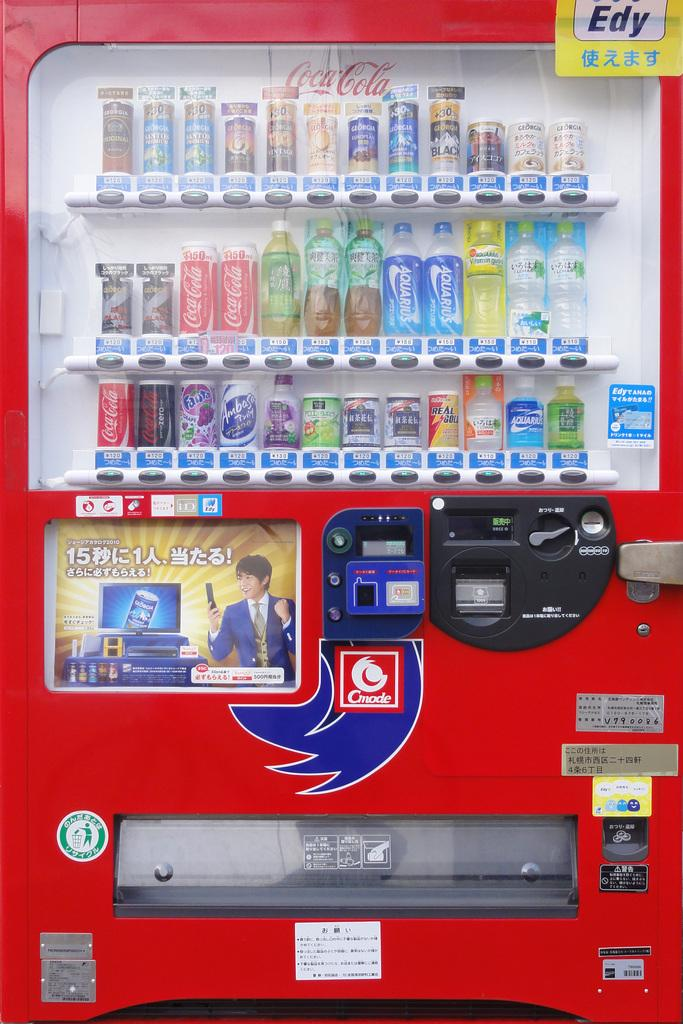Provide a one-sentence caption for the provided image. a red ending machine with several coca cola products. 